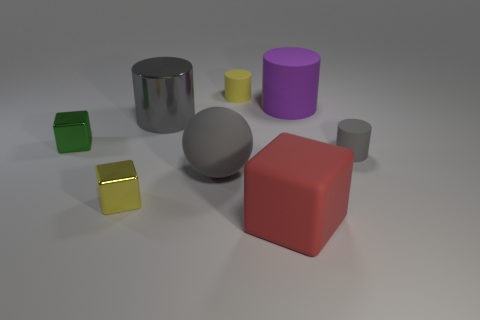How would you describe the lighting in the scene? The lighting in the scene is diffuse, with soft shadows cast underneath and to the sides of the objects. There is no harsh direct light visible; instead, there appears to be a broad light source that creates a gentle illumination over the entire arrangement. Does the lighting affect the color perception of the objects? Yes, the diffuse lighting could influence our perception of the objects' colors, potentially making them appear less saturated and more uniform. The shadows might also subtly shift the hues, adding a slight coolness to the shadowed areas compared to the lit surfaces. 